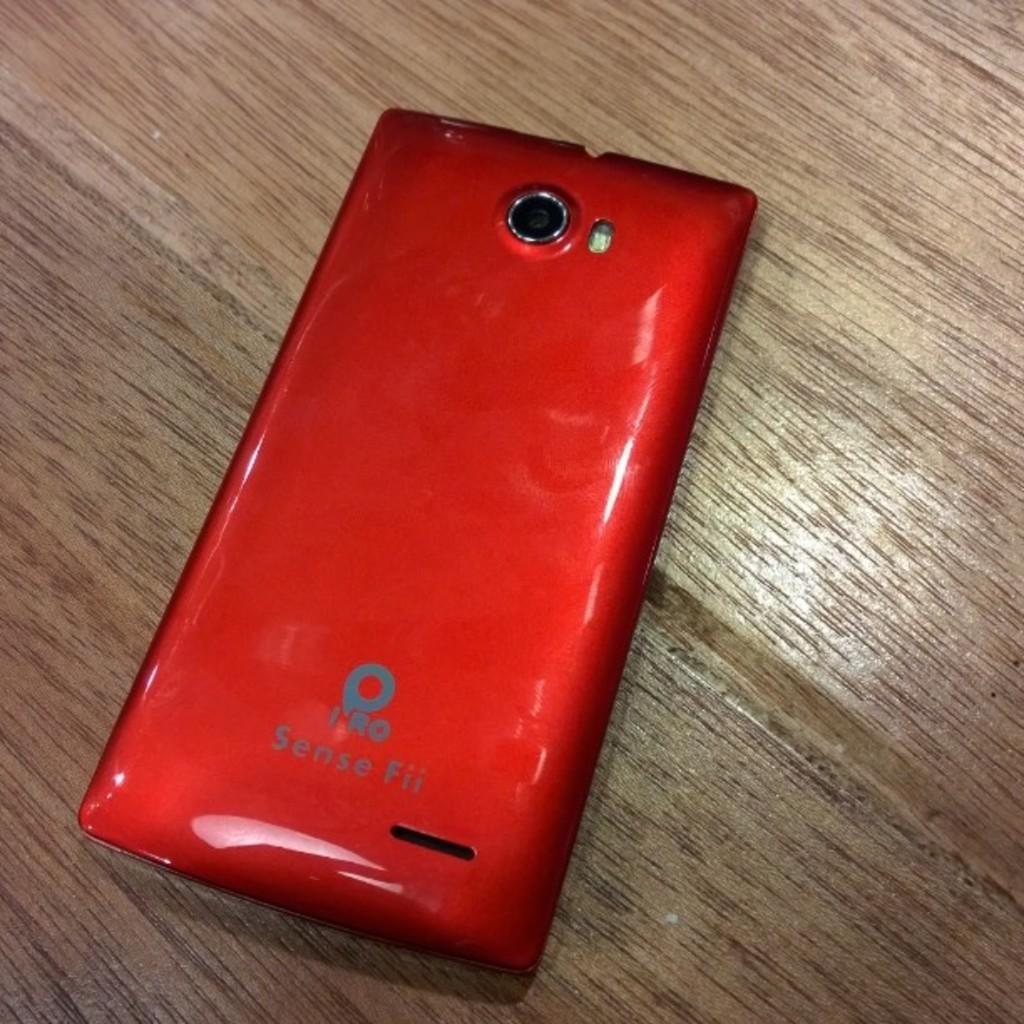<image>
Give a short and clear explanation of the subsequent image. The back side of a red IRO Sense Fii smart phone appears to be in good condition. 